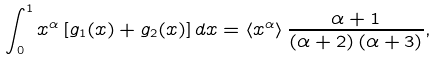<formula> <loc_0><loc_0><loc_500><loc_500>\int _ { 0 } ^ { 1 } x ^ { \alpha } \left [ g _ { 1 } ( x ) + g _ { 2 } ( x ) \right ] d x = \left \langle x ^ { \alpha } \right \rangle \frac { \alpha + 1 } { \left ( \alpha + 2 \right ) \left ( \alpha + 3 \right ) } ,</formula> 